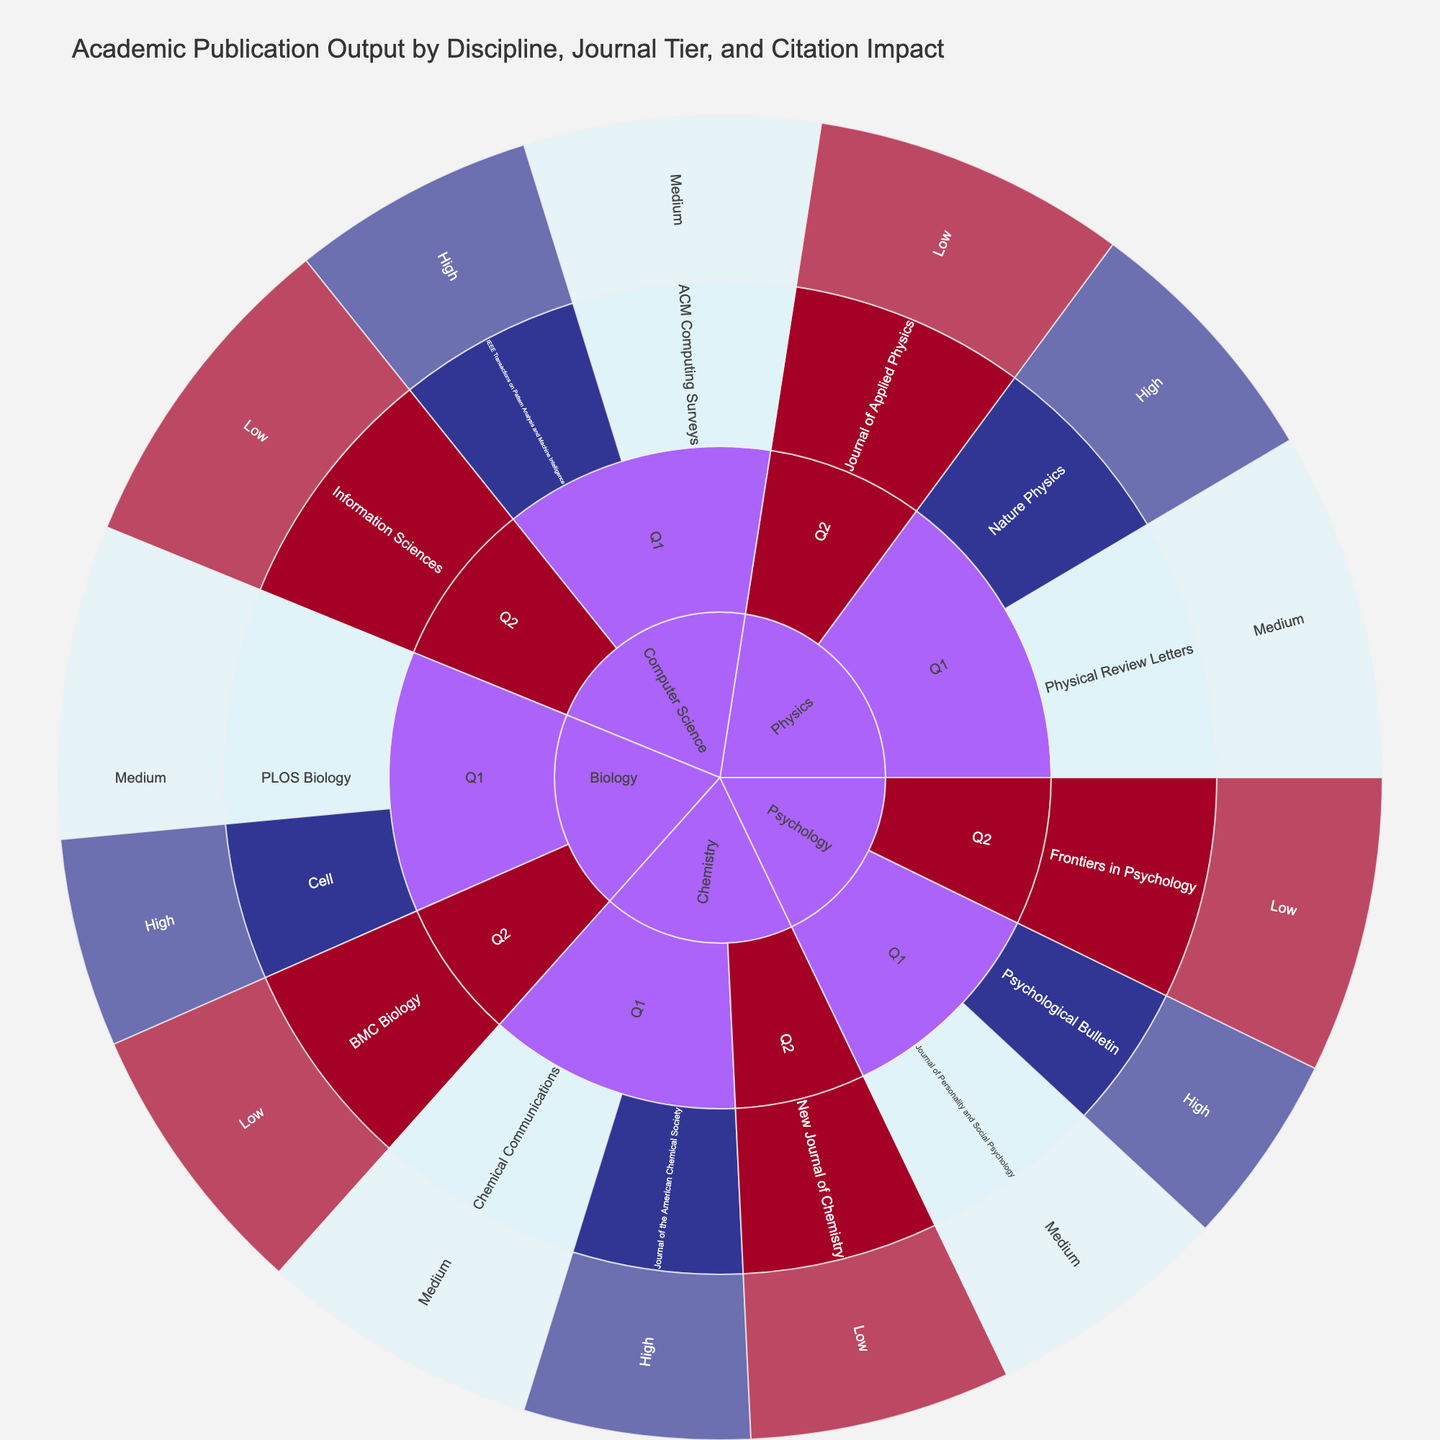Which discipline has the highest number of publications in Q1 journals? To determine this, look at the number of publications within the Q1 journals for each discipline in the figure. Physics has 150 + 200 = 350, Biology has 120 + 180 = 300, Computer Science has 140 + 170 = 310, Chemistry has 130 + 160 = 290, and Psychology has 110 + 140 = 250. Physics has the highest number of publications in Q1 journals.
Answer: Physics What's the total number of publications in journals with low citation impact? Sum the number of publications in journals with low citation impact across all disciplines. This includes Physics (180), Biology (160), Computer Science (190), Chemistry (150), and Psychology (170). Therefore, 180 + 160 + 190 + 150 + 170 = 850.
Answer: 850 Which journal within Biology has a low citation impact? To identify this, locate the Biology discipline and then look for journals categorized under low citation impact. BMC Biology is the journal within Biology that has a low citation impact.
Answer: BMC Biology Compare the number of publications in high citation impact journals between Physics and Chemistry. Which discipline has more? Sum the number of publications in Physics and Chemistry for high citation impact journals. Physics has 150 (Nature Physics), and Chemistry has 130 (Journal of the American Chemical Society). Physics has more publications in high citation impact journals.
Answer: Physics How many publications are there in the highest-tier journals across all disciplines? Sum the publications in Q1 journals across all disciplines. Physics has 150 + 200, Biology has 120 + 180, Computer Science has 140 + 170, Chemistry has 130 + 160, and Psychology has 110 + 140. Therefore, 350 + 300 + 310 + 290 + 250 = 1500.
Answer: 1500 What is the publication difference between journals with medium and low citation impact in Psychology? Calculate the difference in the number of publications between medium and low citation impact journals in Psychology. The medium citation impact journal (Journal of Personality and Social Psychology) has 140 publications and the low citation impact journal (Frontiers in Psychology) has 170 publications. The difference is 170 - 140 = 30.
Answer: 30 Which discipline has the smallest number of high citation impact journal publications? Look for the smallest number of publications in high citation impact journals across all disciplines. Psychology has the smallest with 110 (Psychological Bulletin), compared to other disciplines: Physics (150), Biology (120), Computer Science (140), Chemistry (130).
Answer: Psychology 